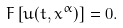<formula> <loc_0><loc_0><loc_500><loc_500>F \left [ u ( t , x ^ { \alpha } ) \right ] = 0 .</formula> 